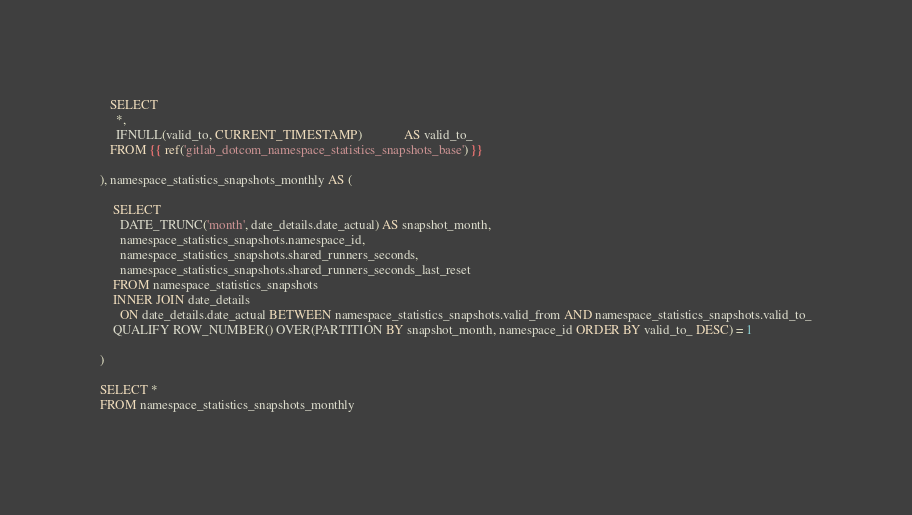<code> <loc_0><loc_0><loc_500><loc_500><_SQL_>
   SELECT
     *,
     IFNULL(valid_to, CURRENT_TIMESTAMP)             AS valid_to_
   FROM {{ ref('gitlab_dotcom_namespace_statistics_snapshots_base') }}

), namespace_statistics_snapshots_monthly AS (
  
    SELECT
      DATE_TRUNC('month', date_details.date_actual) AS snapshot_month,
      namespace_statistics_snapshots.namespace_id,
      namespace_statistics_snapshots.shared_runners_seconds,
      namespace_statistics_snapshots.shared_runners_seconds_last_reset
    FROM namespace_statistics_snapshots
    INNER JOIN date_details
      ON date_details.date_actual BETWEEN namespace_statistics_snapshots.valid_from AND namespace_statistics_snapshots.valid_to_
    QUALIFY ROW_NUMBER() OVER(PARTITION BY snapshot_month, namespace_id ORDER BY valid_to_ DESC) = 1
  
)

SELECT *
FROM namespace_statistics_snapshots_monthly
</code> 